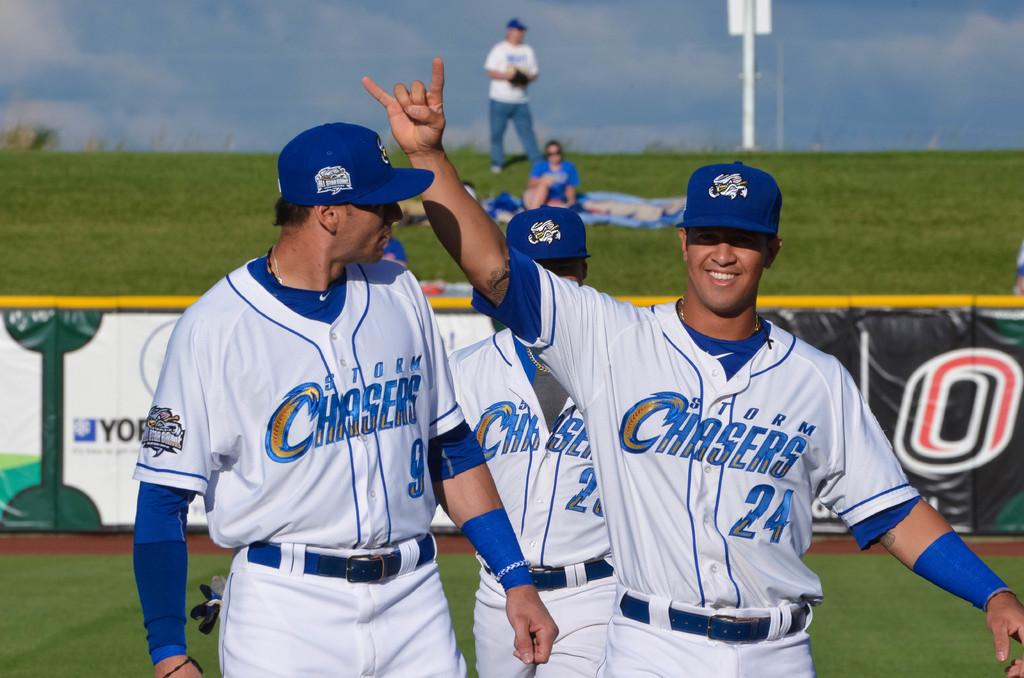<image>
Share a concise interpretation of the image provided. A man in a Storm Chasers uniform holds his hand up in the air. 